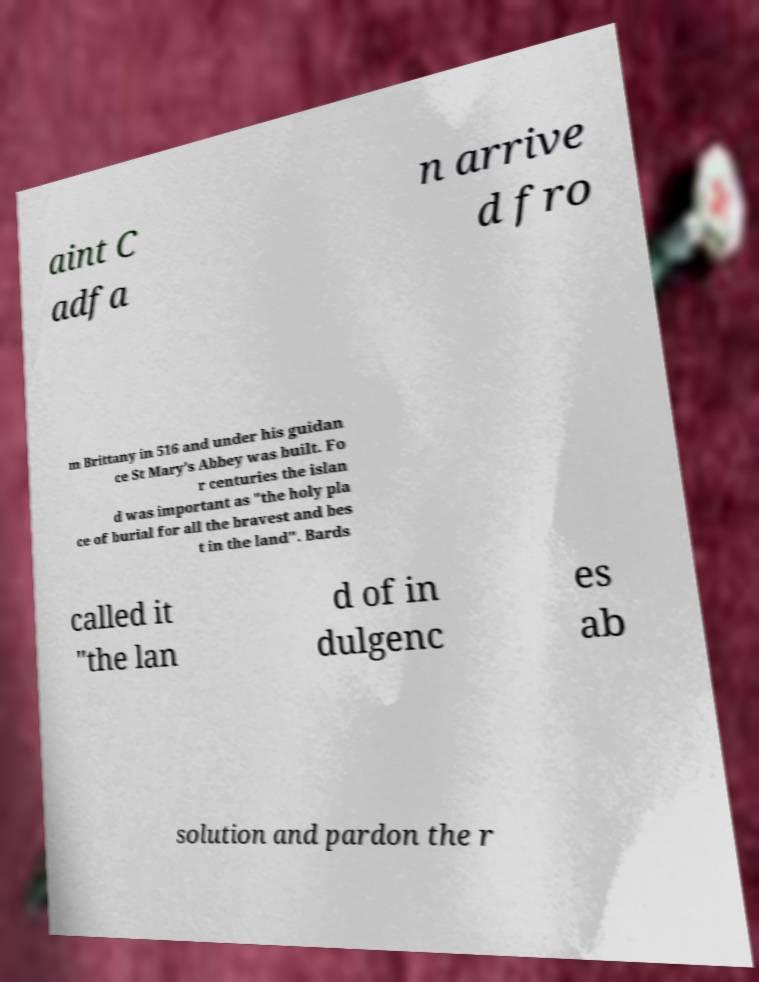What messages or text are displayed in this image? I need them in a readable, typed format. aint C adfa n arrive d fro m Brittany in 516 and under his guidan ce St Mary's Abbey was built. Fo r centuries the islan d was important as "the holy pla ce of burial for all the bravest and bes t in the land". Bards called it "the lan d of in dulgenc es ab solution and pardon the r 